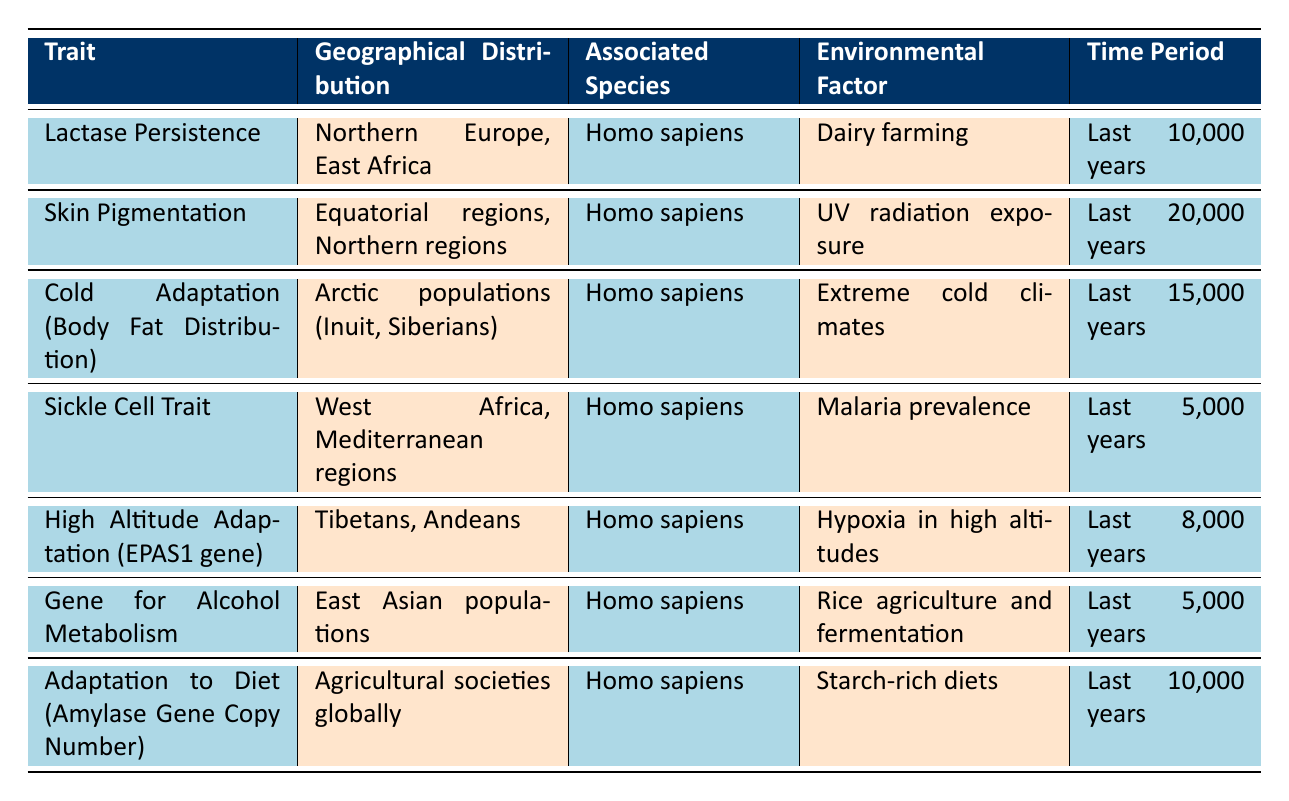What geographical distributions are associated with Lactase Persistence? The table indicates that Lactase Persistence is geographically distributed in Northern Europe and East Africa. The trait and corresponding geographical locations are found in the same row under the respective columns.
Answer: Northern Europe, East Africa Which environmental factor is linked to the Sickle Cell Trait? By checking the row corresponding to the Sickle Cell Trait in the table, we see that the environmental factor is "Malaria prevalence." This information is explicitly stated in the relevant column of that row.
Answer: Malaria prevalence Is High Altitude Adaptation associated with Homo sapiens? In the row for High Altitude Adaptation, the associated species is listed as Homo sapiens. Therefore, this is a direct true/false determination from the data presented.
Answer: Yes How many traits are associated with Arctic populations? The table contains one entry associated with Arctic populations, specifically the Cold Adaptation (Body Fat Distribution). It can be identified in the geographical distribution column for Arctic populations and confirms its singular presence.
Answer: 1 What is the time period for skin pigmentation adaptation? The corresponding row for skin pigmentation indicates that the time period for its adaptation is the last 20,000 years. This detail is explicitly shown in the table under the time period column located next to the skin pigmentation trait.
Answer: Last 20,000 years Which trait is linked to rice agriculture and fermentation? By identifying the row pertaining to the environmental factors, we can see that the Gene for Alcohol Metabolism is linked to rice agriculture and fermentation. This is found in the environmental factor column of that specific row.
Answer: Gene for Alcohol Metabolism Are there any adaptations specifically related to agricultural societies? The table lists one adaptation related to agricultural societies globally, which is "Adaptation to Diet (Amylase Gene Copy Number)." This can be confirmed by locating the respective row in the table.
Answer: Yes Which two traits are associated with Homo sapiens in the last 5,000 years? The table allows us to identify Sickle Cell Trait and Gene for Alcohol Metabolism as the two traits associated with Homo sapiens in the last 5,000 years by checking the time period and associated species columns.
Answer: Sickle Cell Trait, Gene for Alcohol Metabolism How does the number of traits related to extreme cold climates compare to those related to UV radiation exposure? The table indicates that only Cold Adaptation (Body Fat Distribution) is related to extreme cold climates, making a count of 1. Conversely, since skin pigmentation is related to UV radiation exposure, we have a total of 1. Therefore, the comparison show equal numbers of traits for both climates.
Answer: Equal (1 each) 